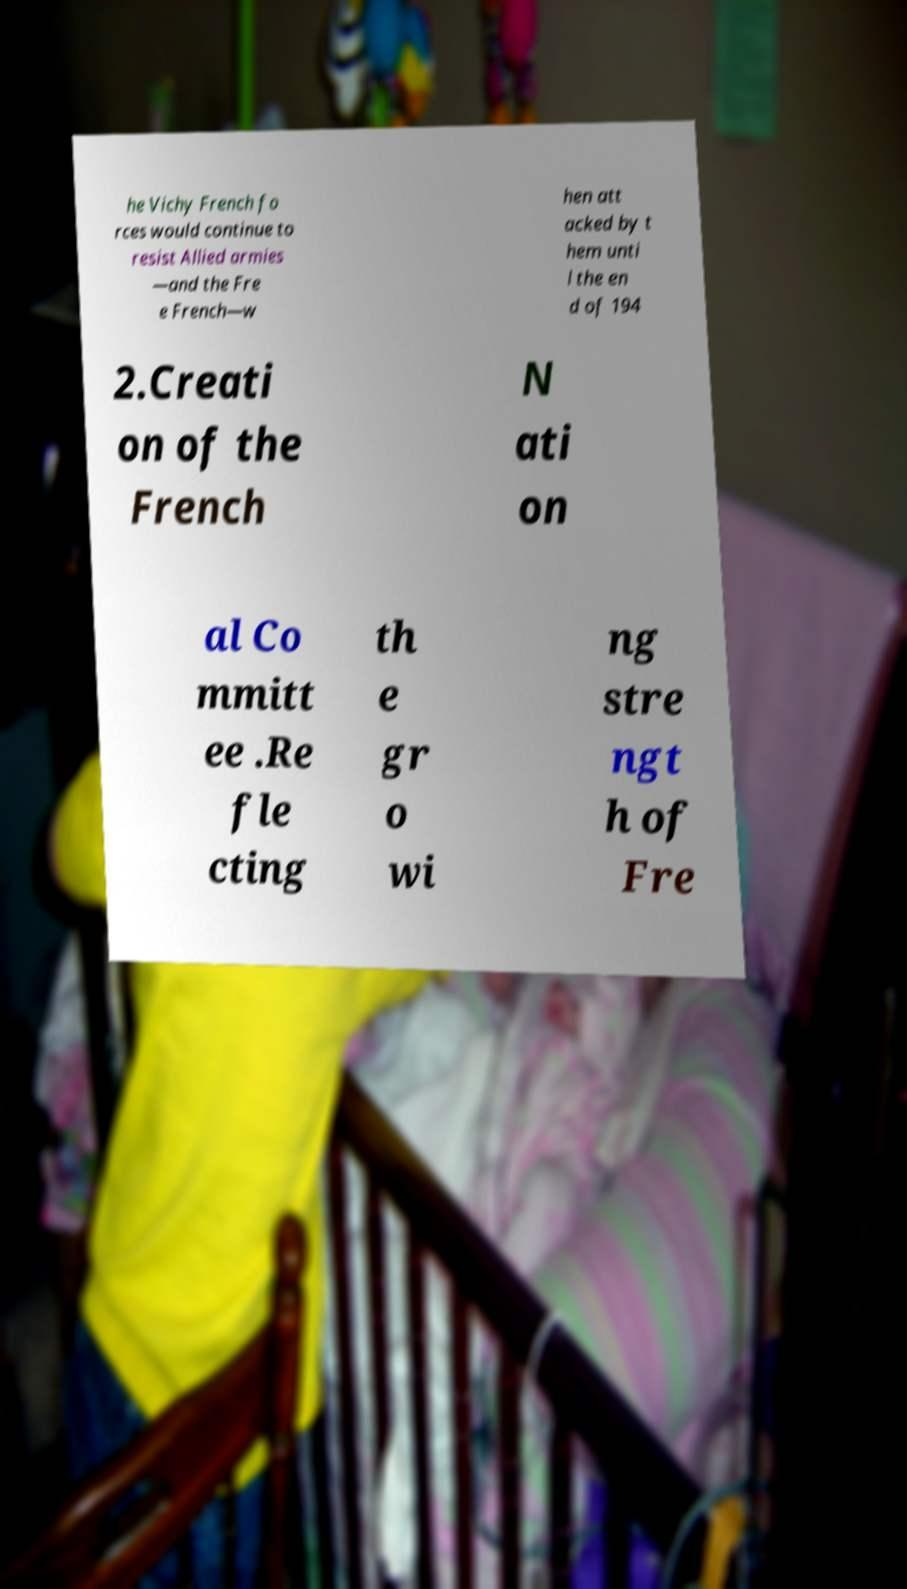Can you accurately transcribe the text from the provided image for me? he Vichy French fo rces would continue to resist Allied armies —and the Fre e French—w hen att acked by t hem unti l the en d of 194 2.Creati on of the French N ati on al Co mmitt ee .Re fle cting th e gr o wi ng stre ngt h of Fre 